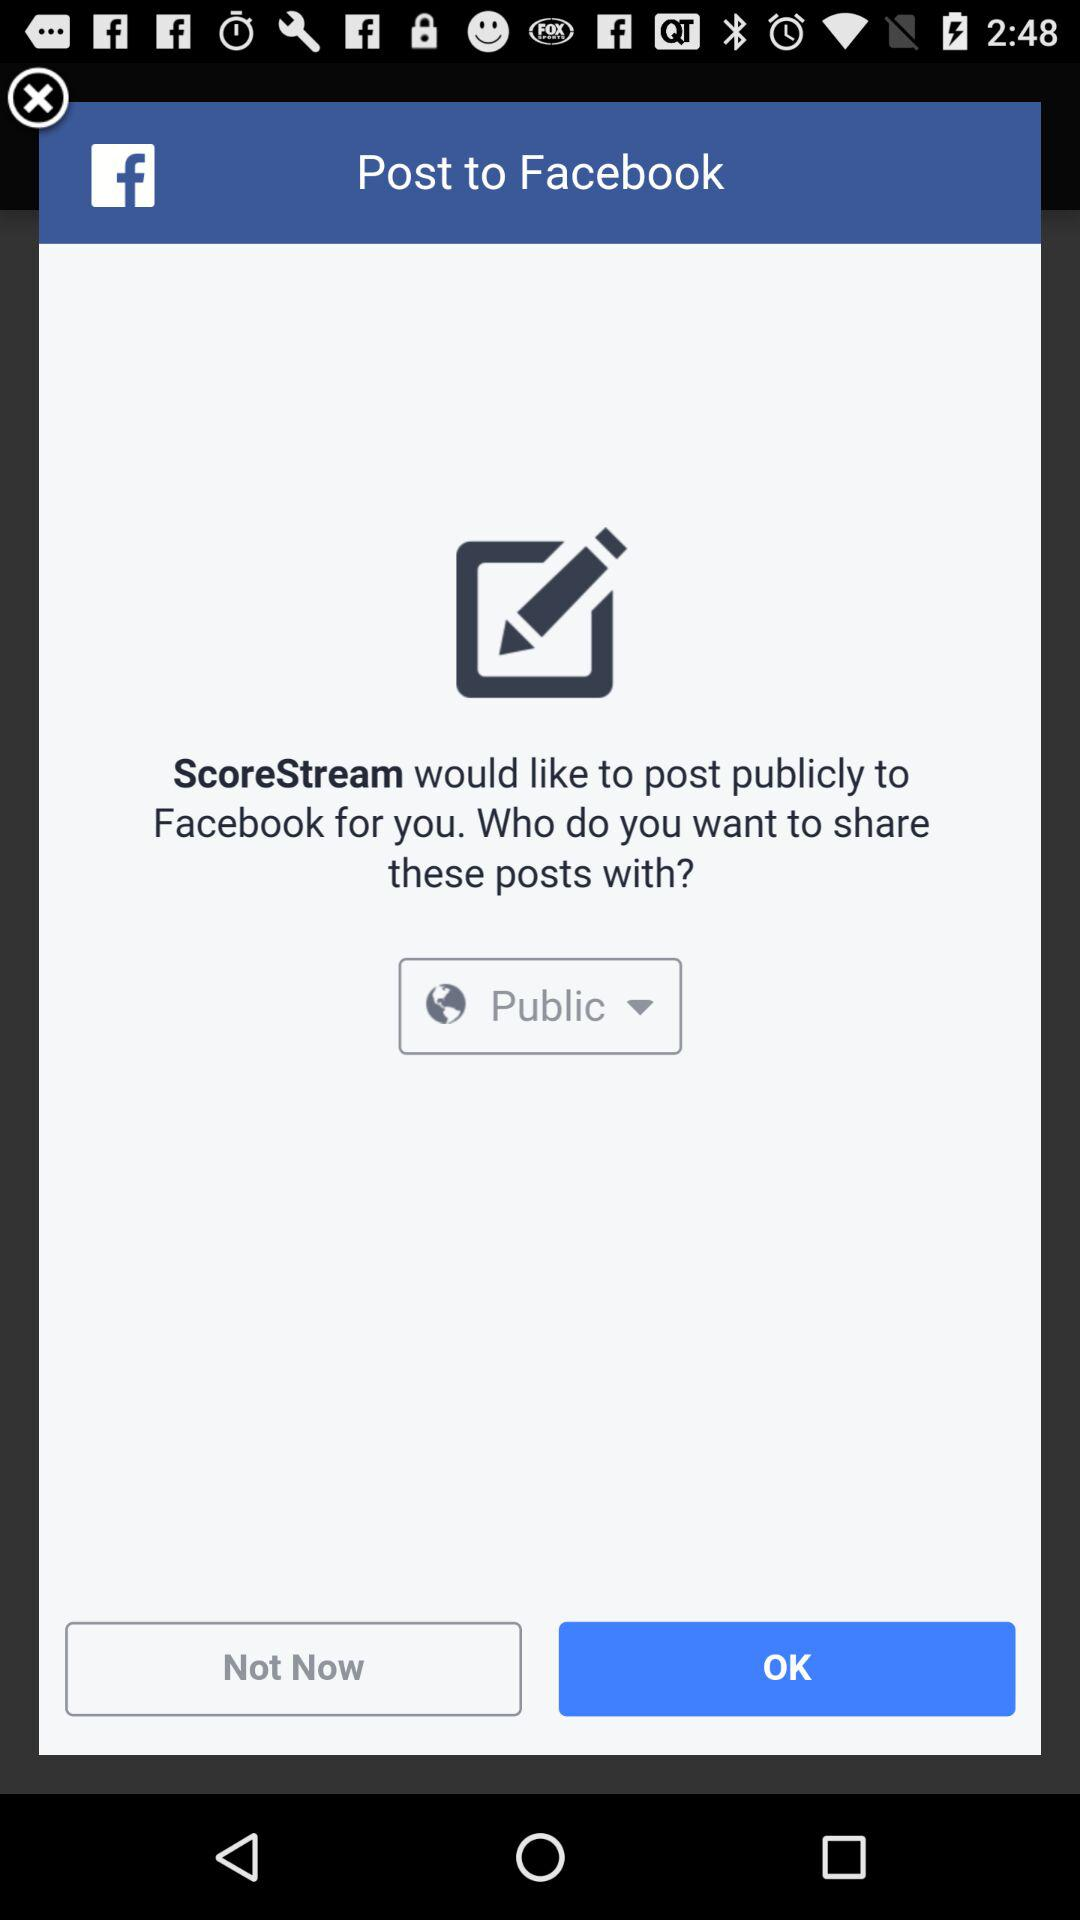What application is asking for the permission? The application is "ScoreStream". 